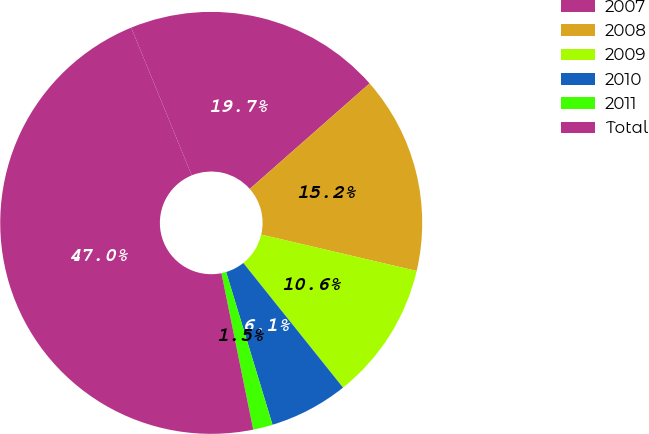Convert chart to OTSL. <chart><loc_0><loc_0><loc_500><loc_500><pie_chart><fcel>2007<fcel>2008<fcel>2009<fcel>2010<fcel>2011<fcel>Total<nl><fcel>19.7%<fcel>15.15%<fcel>10.6%<fcel>6.05%<fcel>1.5%<fcel>47.0%<nl></chart> 